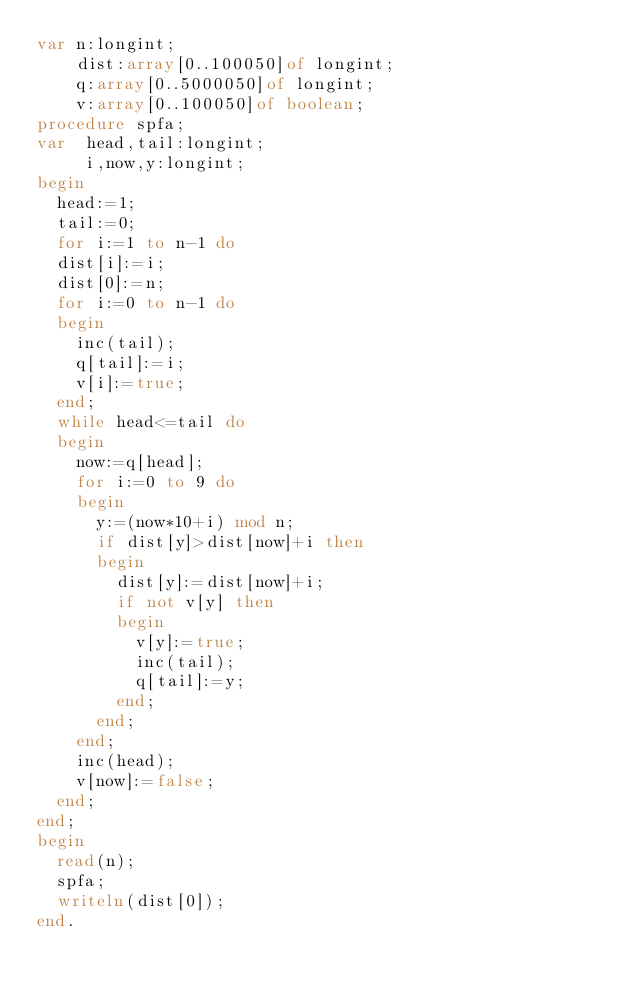<code> <loc_0><loc_0><loc_500><loc_500><_Pascal_>var n:longint;
    dist:array[0..100050]of longint;
    q:array[0..5000050]of longint;
    v:array[0..100050]of boolean;
procedure spfa;
var  head,tail:longint;
     i,now,y:longint;
begin
  head:=1;
  tail:=0;
  for i:=1 to n-1 do
  dist[i]:=i;
  dist[0]:=n;
  for i:=0 to n-1 do
  begin
    inc(tail);
    q[tail]:=i;
    v[i]:=true;
  end;
  while head<=tail do
  begin
    now:=q[head];
    for i:=0 to 9 do
    begin
      y:=(now*10+i) mod n;
      if dist[y]>dist[now]+i then
      begin
        dist[y]:=dist[now]+i;
        if not v[y] then
        begin
          v[y]:=true;
          inc(tail);
          q[tail]:=y;
        end;
      end;
    end;
    inc(head);
    v[now]:=false;
  end;
end;
begin
  read(n);
  spfa;
  writeln(dist[0]);
end.</code> 